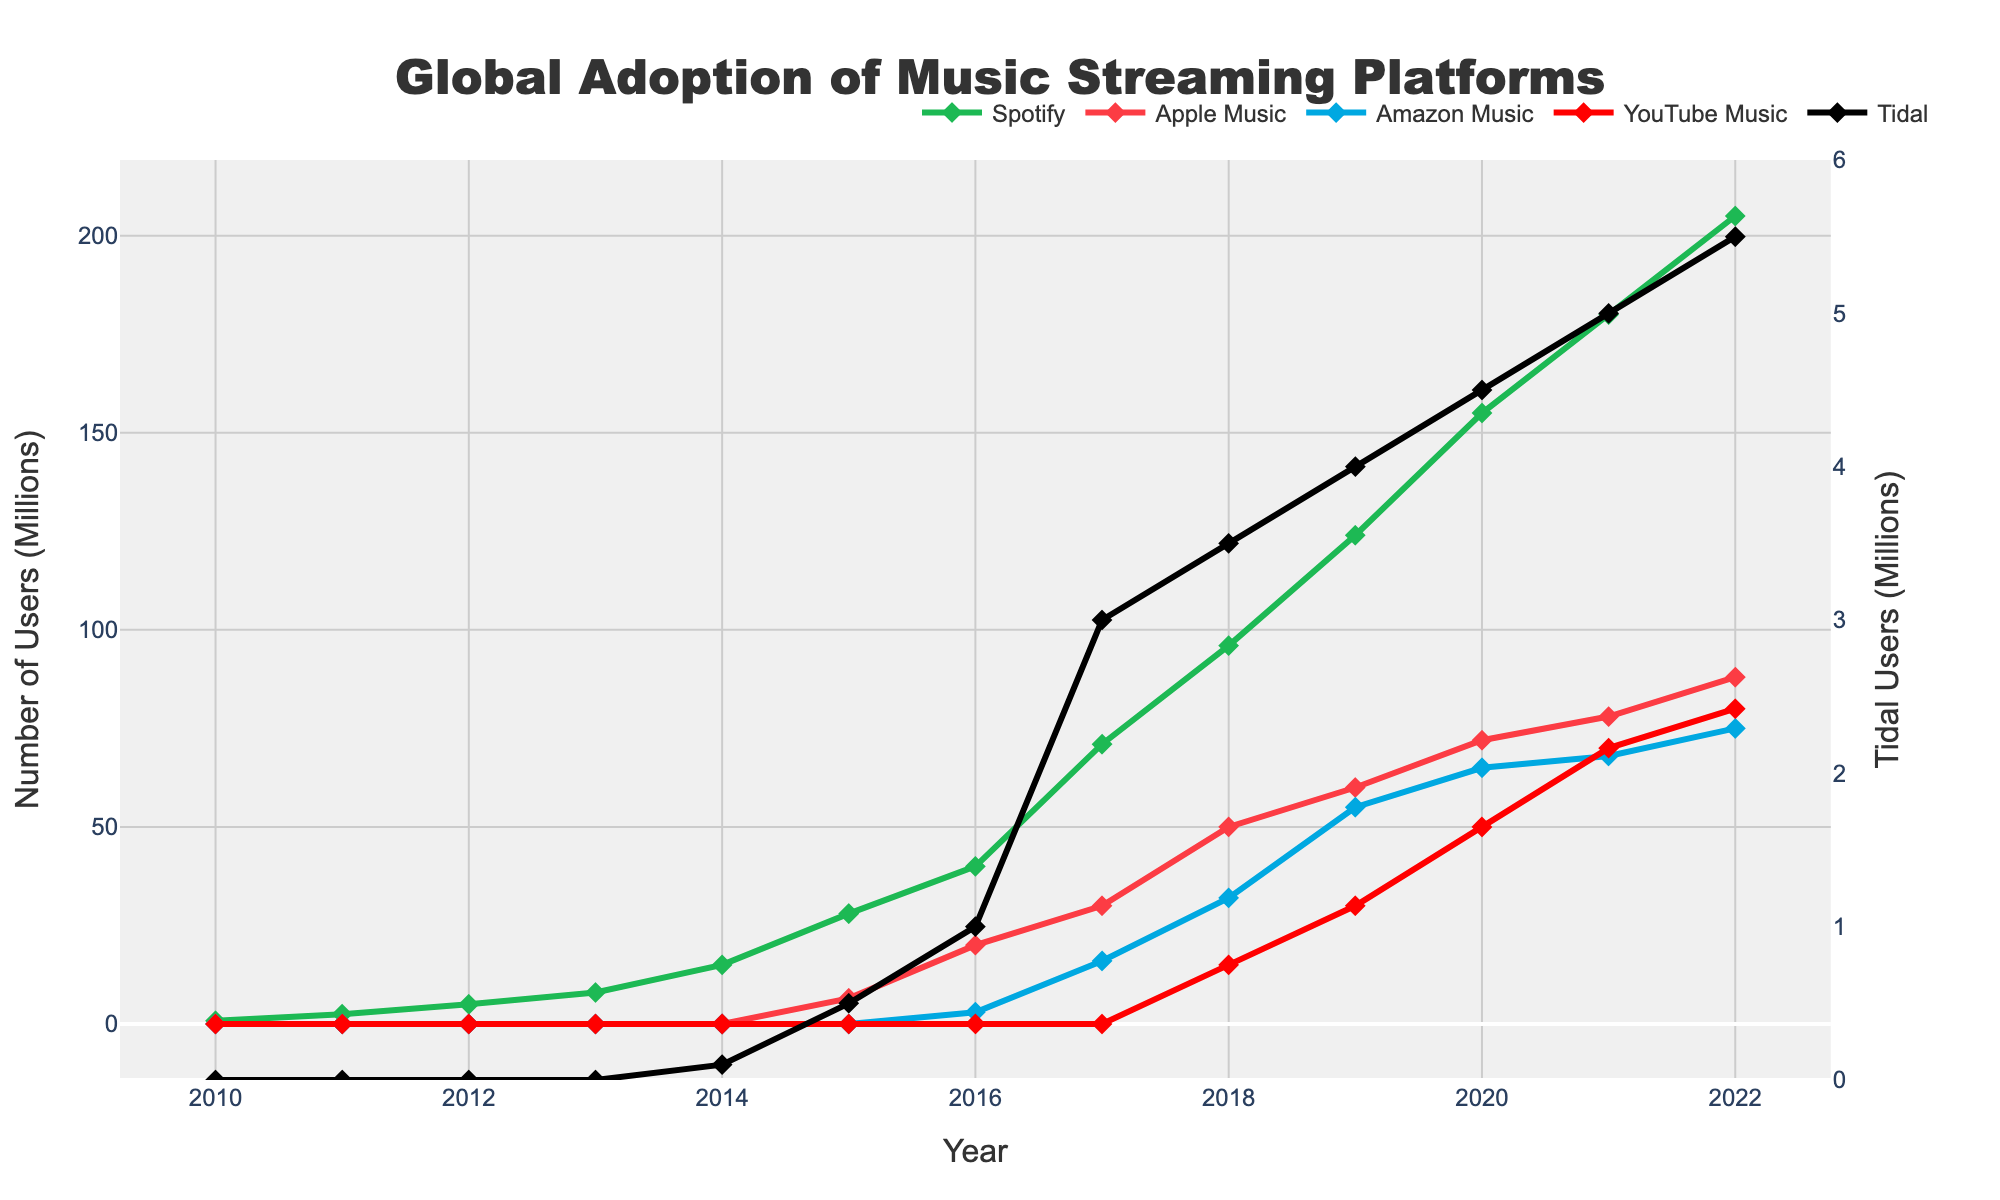What year did Spotify see the largest increase in user adoption? To determine the year with the largest increase in Spotify's users, we need to check the difference in user numbers between consecutive years. From the data: 2011-2010 = 1.7M, 2012-2011 = 2.5M, 2013-2012 = 3.0M, 2014-2013 = 7.0M, 2015-2014 = 13.0M, 2016-2015 = 12.0M, 2017-2016 = 31.0M, 2018-2017 = 25.0M, 2019-2018 = 28.0M, 2020-2019 = 31.0M, 2021-2020 = 25.0M, 2022-2021 = 25.0M. The largest increase was 2017 with 31.0M users.
Answer: 2017 Which platform had the second highest number of users in 2022? In the year 2022, the number of users for each platform is as follows: Spotify = 205M, Apple Music = 88M, Amazon Music = 75M, YouTube Music = 80M, Tidal = 5.5M. Sorting these numbers, the second highest is Apple Music with 88M users.
Answer: Apple Music What was the total number of users across all platforms in 2020? To find the total number of users in 2020, sum the user numbers for each platform: Spotify = 155M, Apple Music = 72M, Amazon Music = 65M, YouTube Music = 50M, Tidal = 4.5M. 155 + 72 + 65 + 50 + 4.5 = 346.5.
Answer: 346.5M By how much did Amazon Music's user base grow from 2019 to 2021? To calculate the growth, subtract the number of users in 2019 from the number in 2021. 2021 has 68M users, and 2019 has 55M users for Amazon Music. Thus, 68 - 55 = 13.
Answer: 13M Which platform had the slowest growth rate from 2014 to 2022? To find the platform with the slowest growth rate, calculate the increase for each platform from 2014 to 2022. Spotify: 205 - 15 = 190M, Apple Music: 88 - 0 = 88M, Amazon Music: 75 - 0 = 75M, YouTube Music: 80 - 0 = 80M, Tidal: 5.5 - 0.1 = 5.4M. Tidal had the smallest increase of 5.4M.
Answer: Tidal What is the average annual growth rate of YouTube Music from 2016 to 2022? First, find the growth: 80M (2022) - 0M (2016) = 80M. The number of years is 2022 - 2016 = 6 years. To find the average annual growth rate, divide the total growth by the number of years: 80M / 6 = 13.33M per year.
Answer: 13.33M per year Which platform showed a consistent growth each year from 2010 to 2022? Only Spotify has data starting from 2010 and shows a consistent increase every year without any drop. Reviewing other platforms shows either a lack of data in earlier years or inconsistent growth.
Answer: Spotify In 2018, how did the user numbers of Amazon Music compare to Apple Music? In 2018, Amazon Music had 32M users while Apple Music had 50M users. Amazon Music had fewer users.
Answer: Fewer By how much did Tidal's user count increase from 2014 to 2022? In 2014, Tidal had 0.1M users, and in 2022, it had 5.5M users. The increase is 5.5 - 0.1 = 5.4M users.
Answer: 5.4M Which year did Tidal start showing data for user counts? From the data provided, Tidal shows user data starting in 2014.
Answer: 2014 